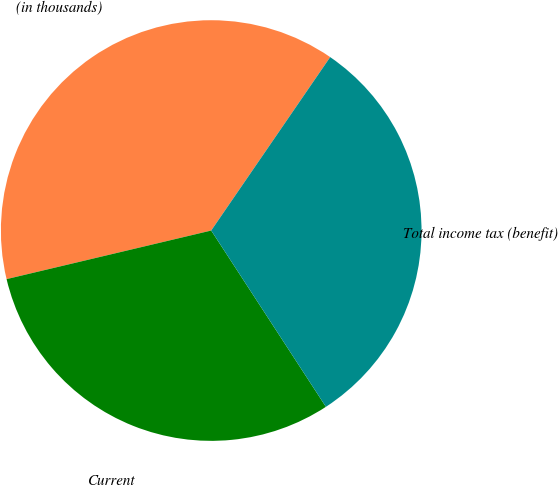Convert chart. <chart><loc_0><loc_0><loc_500><loc_500><pie_chart><fcel>(in thousands)<fcel>Current<fcel>Total income tax (benefit)<nl><fcel>38.28%<fcel>30.47%<fcel>31.25%<nl></chart> 